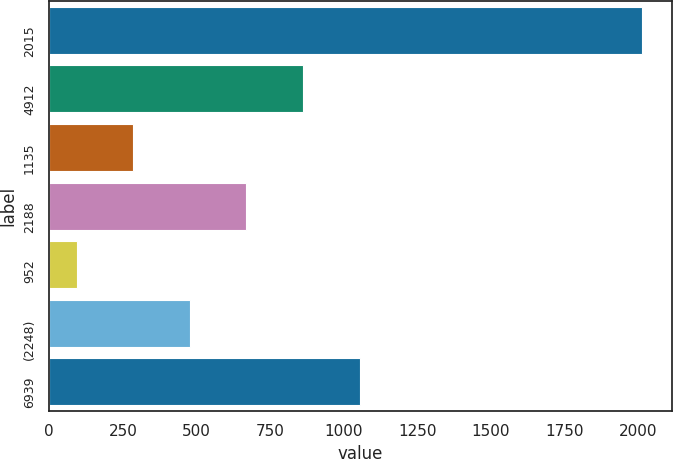Convert chart to OTSL. <chart><loc_0><loc_0><loc_500><loc_500><bar_chart><fcel>2015<fcel>4912<fcel>1135<fcel>2188<fcel>952<fcel>(2248)<fcel>6939<nl><fcel>2014<fcel>861.64<fcel>285.46<fcel>669.58<fcel>93.4<fcel>477.52<fcel>1053.7<nl></chart> 